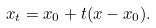<formula> <loc_0><loc_0><loc_500><loc_500>x _ { t } = x _ { 0 } + t ( x - x _ { 0 } ) .</formula> 